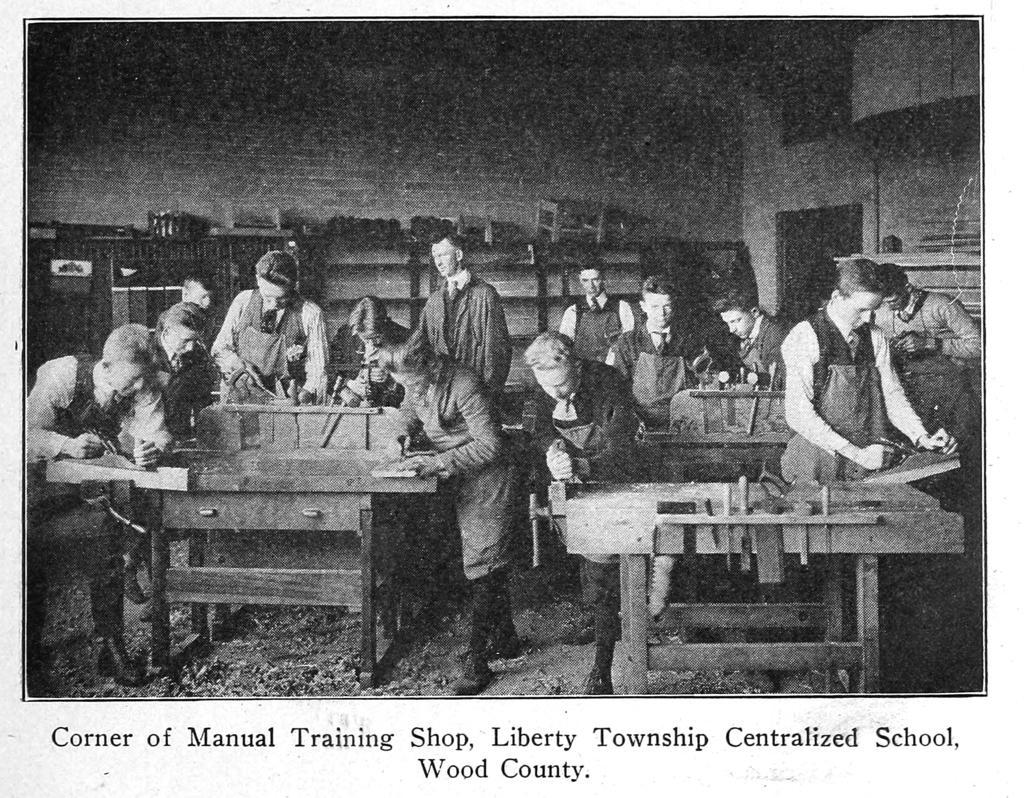Can you describe this image briefly? In this image, there are group of people standing and doing furniture work. The background wall is of brick. This image is a photo of picture taken inside a hall. 